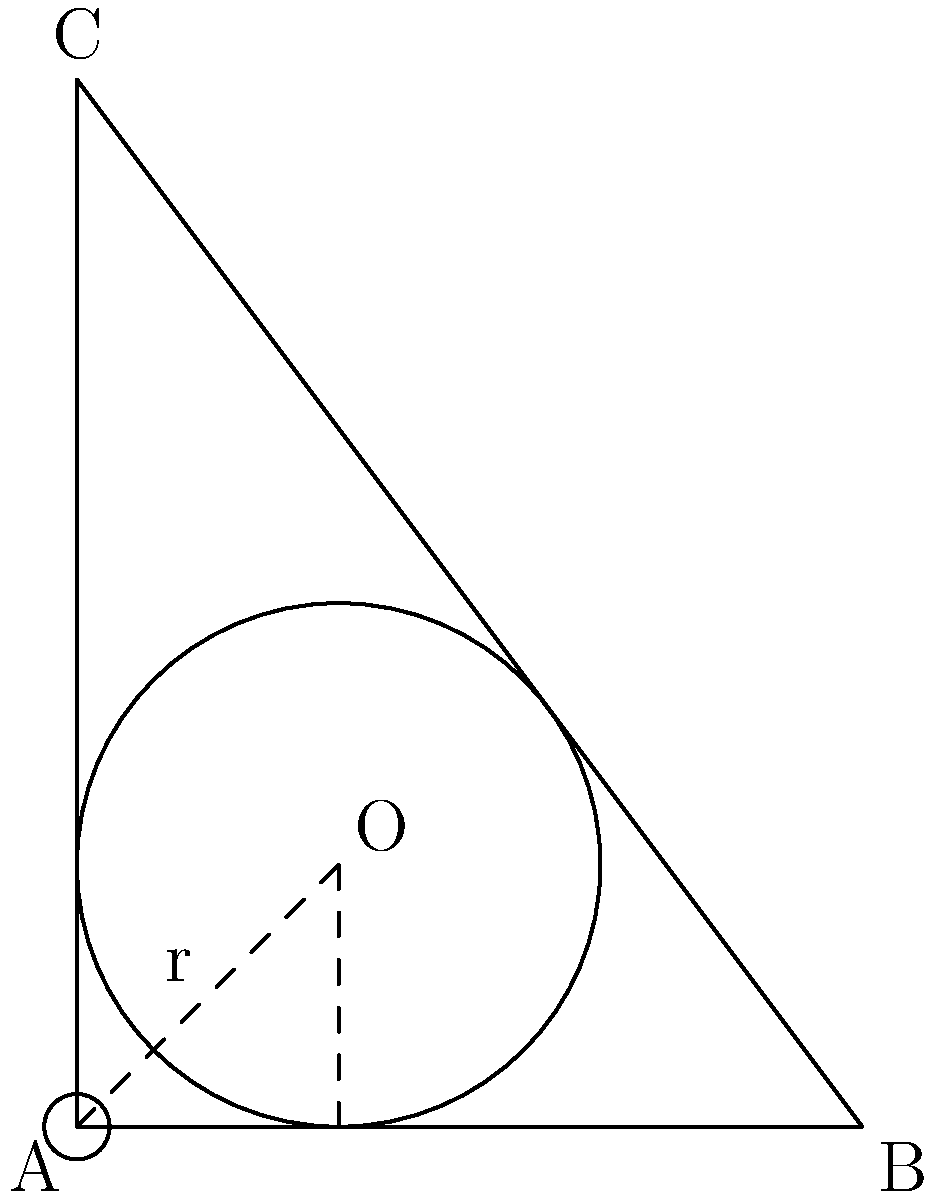In a right-angled triangle ABC with legs of length 6 and 8 units, an inscribed circle touches all three sides of the triangle. As a historical reenactment enthusiast with a keen interest in geometry, determine the radius of this inscribed circle. Let's approach this step-by-step:

1) In a right triangle, if $r$ is the radius of the inscribed circle, and $a$, $b$ are the lengths of the two legs, then the area of the triangle can be expressed in two ways:

   $A = \frac{1}{2}ab = (a + b + c)r$

   where $c$ is the hypotenuse.

2) We know $a = 6$ and $b = 8$. Let's calculate $c$ using the Pythagorean theorem:

   $c^2 = a^2 + b^2 = 6^2 + 8^2 = 36 + 64 = 100$
   $c = 10$

3) Now we can set up our equation:

   $\frac{1}{2}(6)(8) = (6 + 8 + 10)r$

4) Simplify the left side:

   $24 = 24r$

5) Solve for $r$:

   $r = 1$

Therefore, the radius of the inscribed circle is 1 unit.
Answer: $1$ unit 